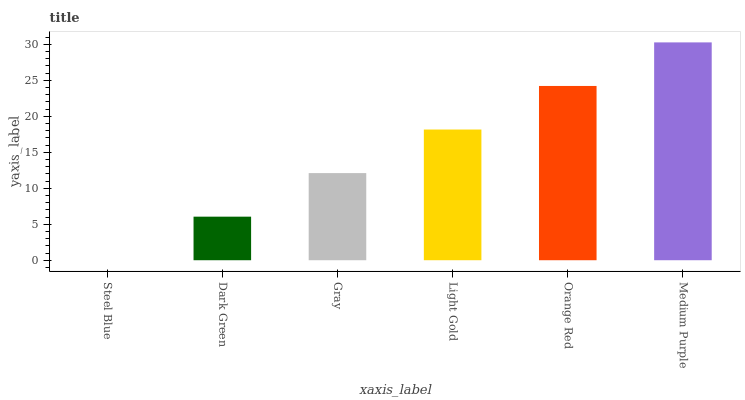Is Steel Blue the minimum?
Answer yes or no. Yes. Is Medium Purple the maximum?
Answer yes or no. Yes. Is Dark Green the minimum?
Answer yes or no. No. Is Dark Green the maximum?
Answer yes or no. No. Is Dark Green greater than Steel Blue?
Answer yes or no. Yes. Is Steel Blue less than Dark Green?
Answer yes or no. Yes. Is Steel Blue greater than Dark Green?
Answer yes or no. No. Is Dark Green less than Steel Blue?
Answer yes or no. No. Is Light Gold the high median?
Answer yes or no. Yes. Is Gray the low median?
Answer yes or no. Yes. Is Gray the high median?
Answer yes or no. No. Is Light Gold the low median?
Answer yes or no. No. 